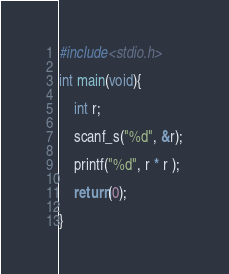Convert code to text. <code><loc_0><loc_0><loc_500><loc_500><_C_>#include<stdio.h>

int main(void){

	int r;

	scanf_s("%d", &r);

	printf("%d", r * r );

	return(0);

}</code> 